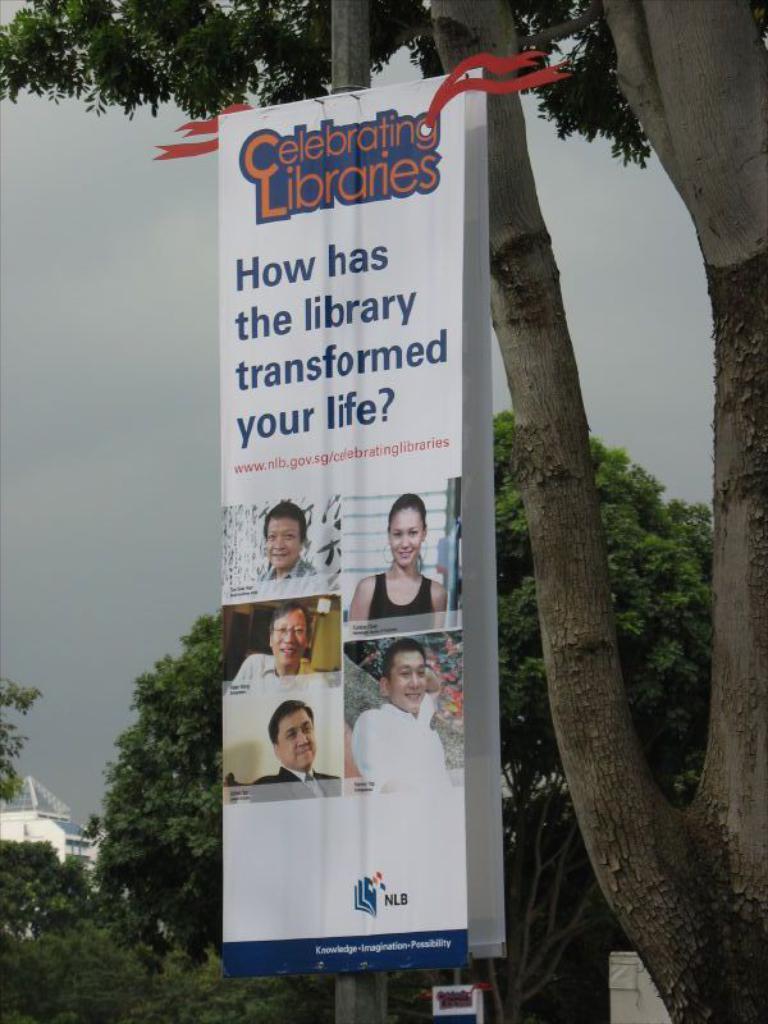In one or two sentences, can you explain what this image depicts? In this picture we can see a banner, trees, building and in the background we can see the sky. 